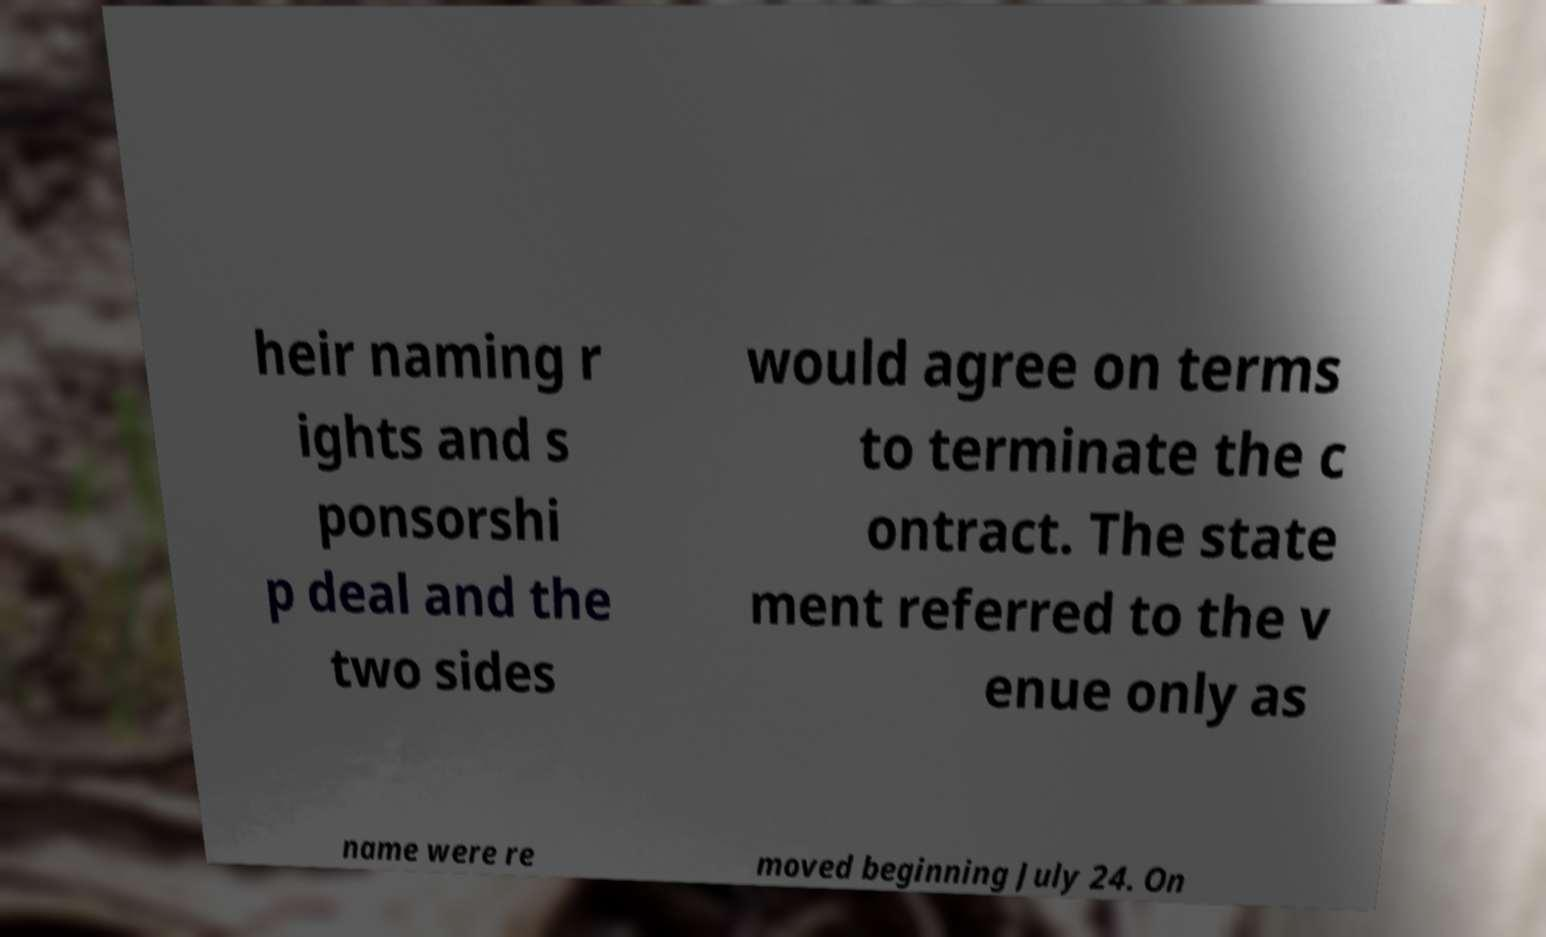Can you read and provide the text displayed in the image?This photo seems to have some interesting text. Can you extract and type it out for me? heir naming r ights and s ponsorshi p deal and the two sides would agree on terms to terminate the c ontract. The state ment referred to the v enue only as name were re moved beginning July 24. On 